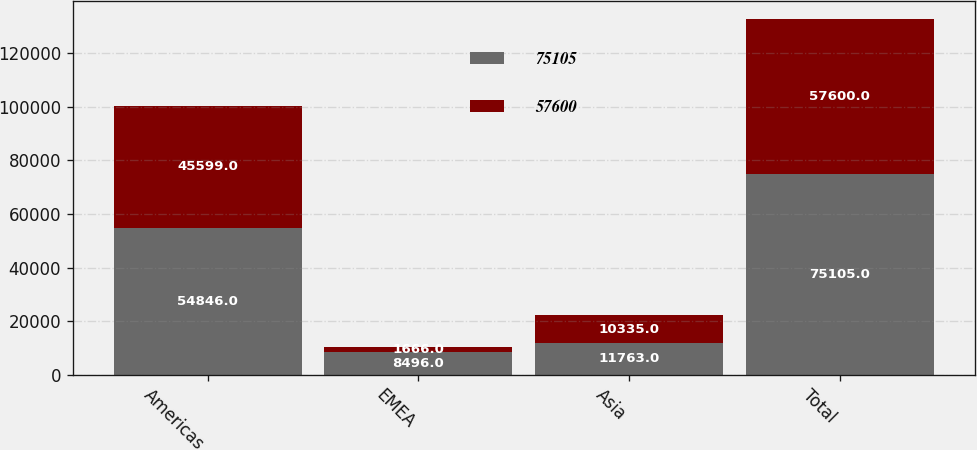Convert chart to OTSL. <chart><loc_0><loc_0><loc_500><loc_500><stacked_bar_chart><ecel><fcel>Americas<fcel>EMEA<fcel>Asia<fcel>Total<nl><fcel>75105<fcel>54846<fcel>8496<fcel>11763<fcel>75105<nl><fcel>57600<fcel>45599<fcel>1666<fcel>10335<fcel>57600<nl></chart> 